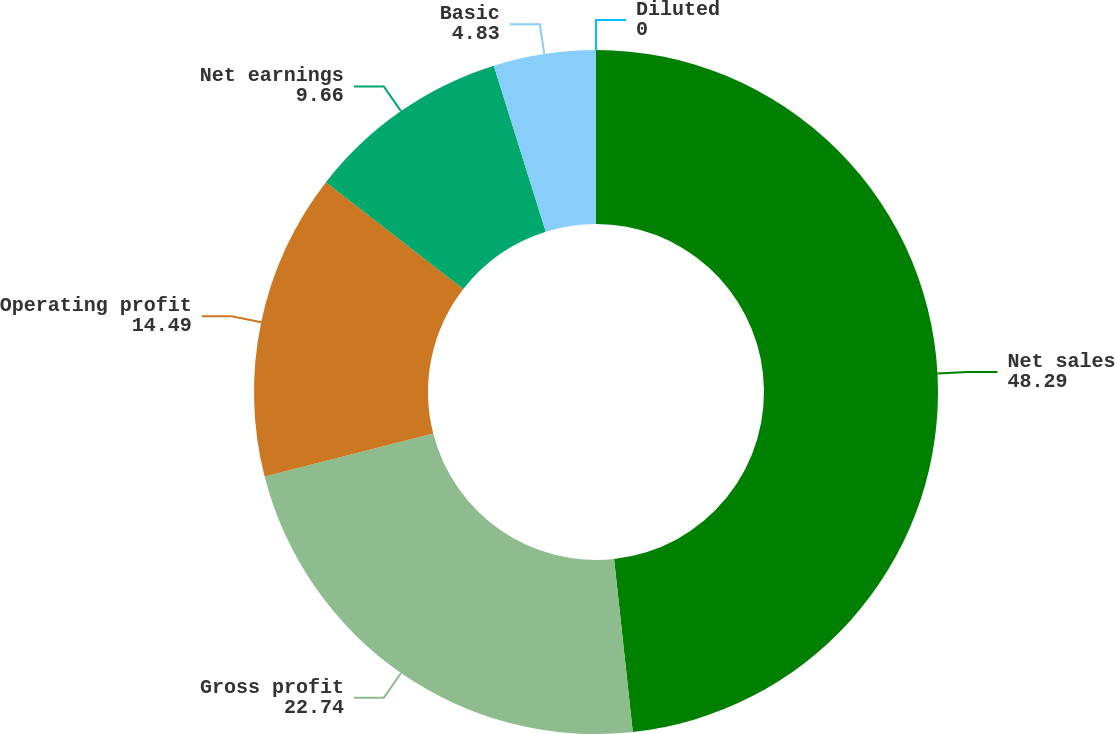<chart> <loc_0><loc_0><loc_500><loc_500><pie_chart><fcel>Net sales<fcel>Gross profit<fcel>Operating profit<fcel>Net earnings<fcel>Basic<fcel>Diluted<nl><fcel>48.29%<fcel>22.74%<fcel>14.49%<fcel>9.66%<fcel>4.83%<fcel>0.0%<nl></chart> 